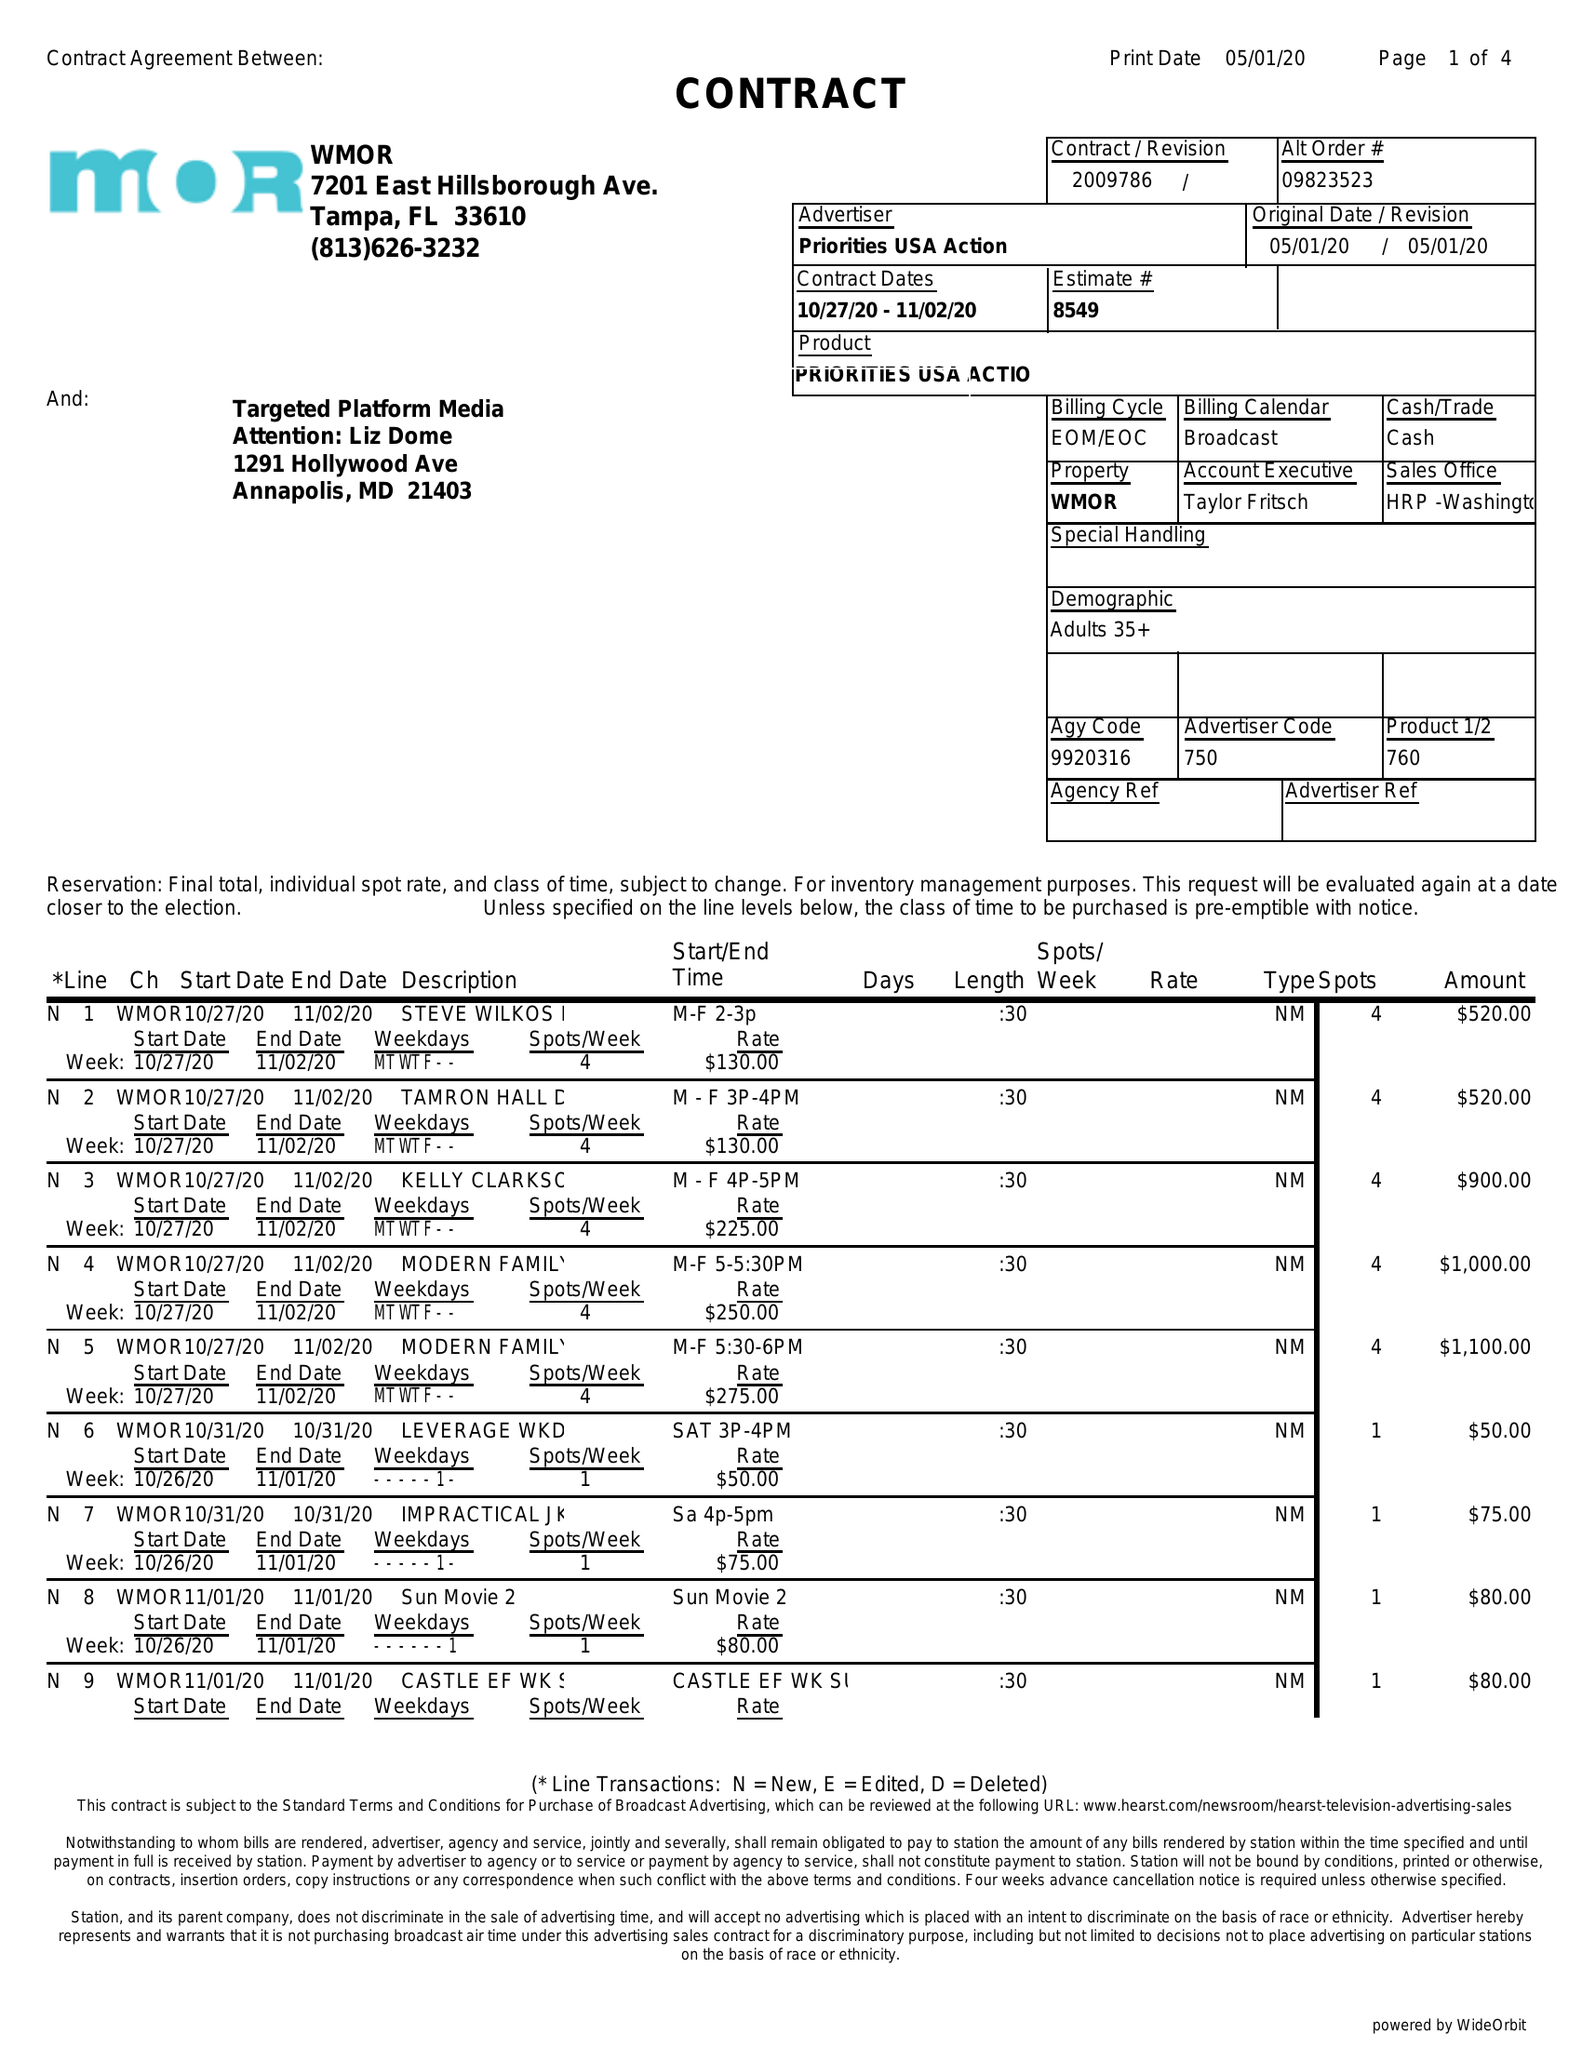What is the value for the contract_num?
Answer the question using a single word or phrase. 2009786 